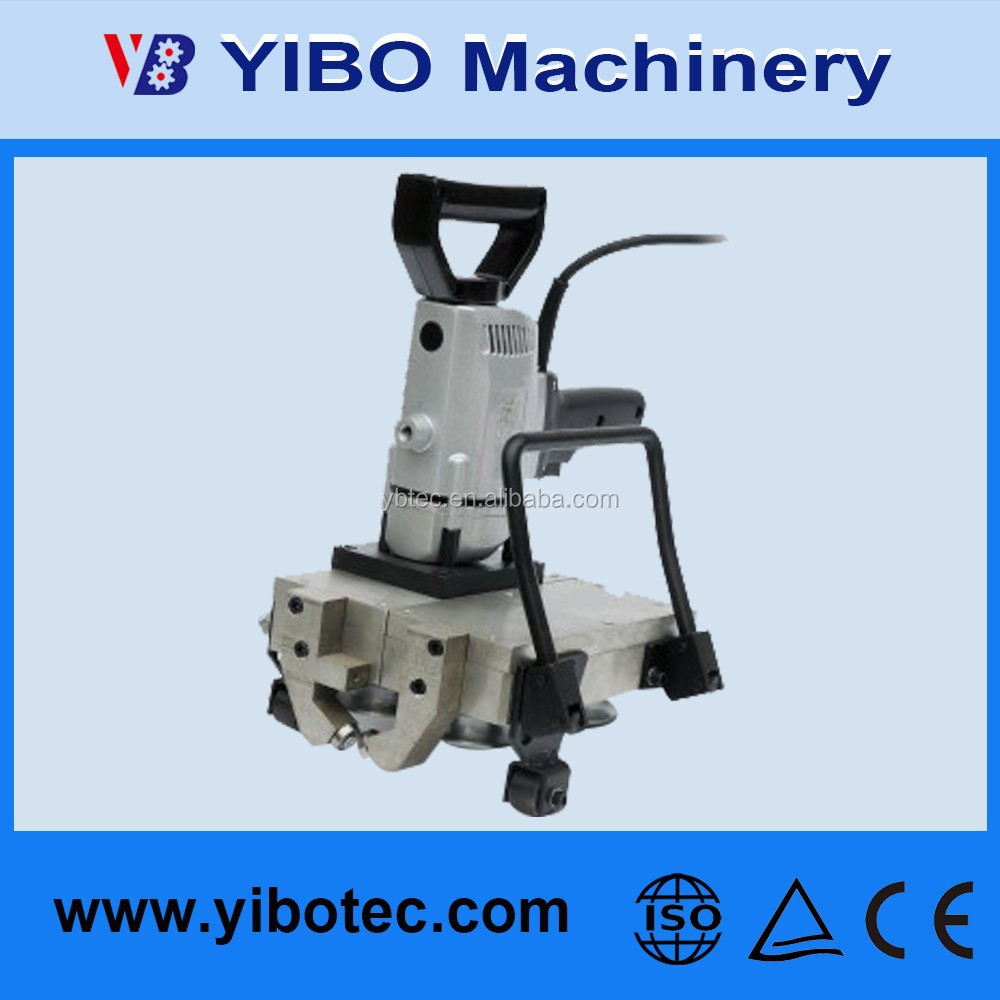What specific industries or applications might benefit most from this type of machinery? This type of machinery, given its robust construction and compliance with international standards, is likely well-suited for industries such as manufacturing, construction, and heavy equipment maintenance. It's ideal for tasks that require precision and durability, such as metalworking, automated assembly lines, and heavy-duty material cutting or shaping. The CE and ISO certifications further assure users of its reliability and safety, making it a valuable addition to industrial operations requiring stringent quality control. 